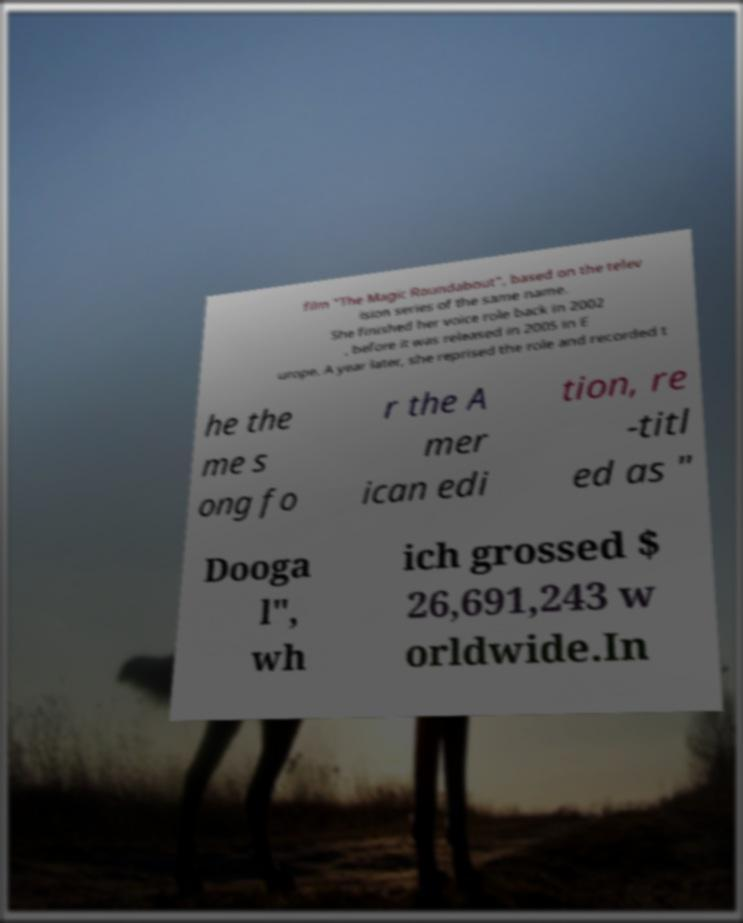What messages or text are displayed in this image? I need them in a readable, typed format. film "The Magic Roundabout", based on the telev ision series of the same name. She finished her voice role back in 2002 , before it was released in 2005 in E urope. A year later, she reprised the role and recorded t he the me s ong fo r the A mer ican edi tion, re -titl ed as " Dooga l", wh ich grossed $ 26,691,243 w orldwide.In 